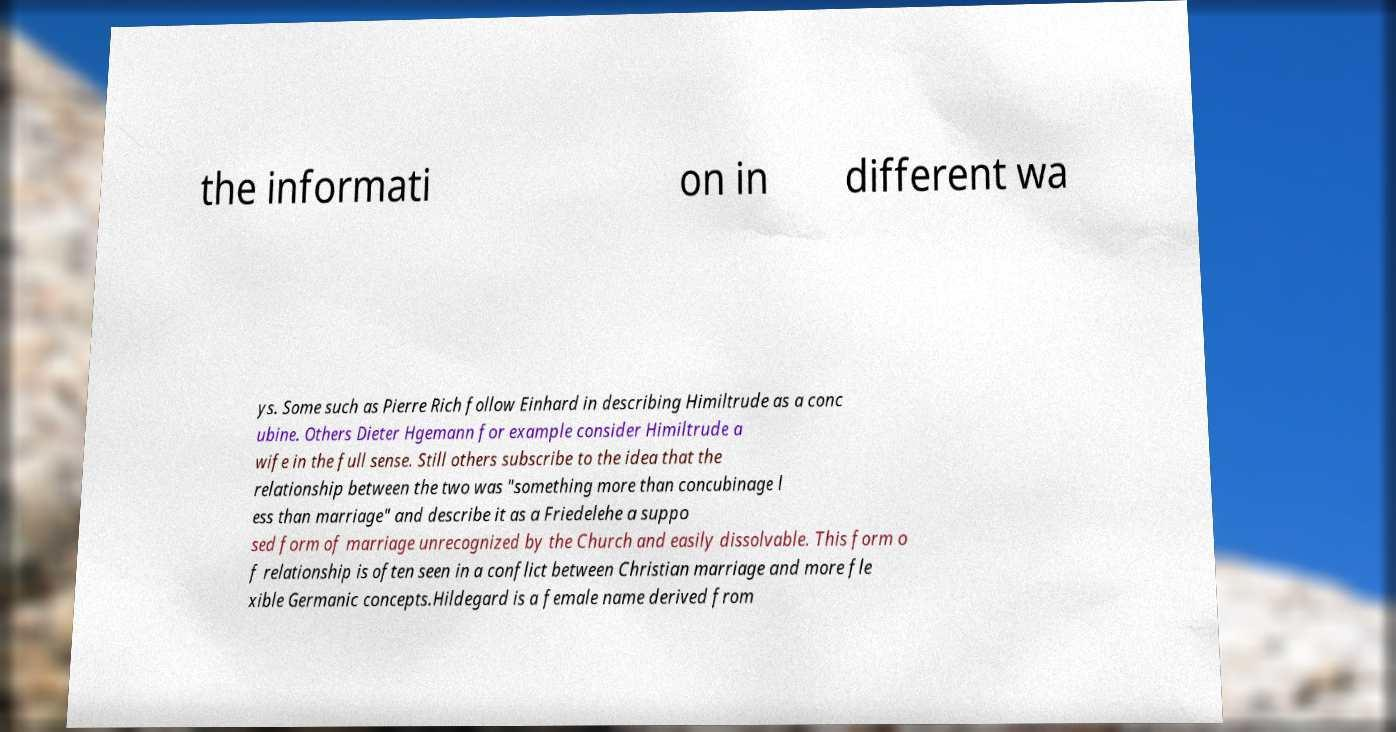There's text embedded in this image that I need extracted. Can you transcribe it verbatim? the informati on in different wa ys. Some such as Pierre Rich follow Einhard in describing Himiltrude as a conc ubine. Others Dieter Hgemann for example consider Himiltrude a wife in the full sense. Still others subscribe to the idea that the relationship between the two was "something more than concubinage l ess than marriage" and describe it as a Friedelehe a suppo sed form of marriage unrecognized by the Church and easily dissolvable. This form o f relationship is often seen in a conflict between Christian marriage and more fle xible Germanic concepts.Hildegard is a female name derived from 